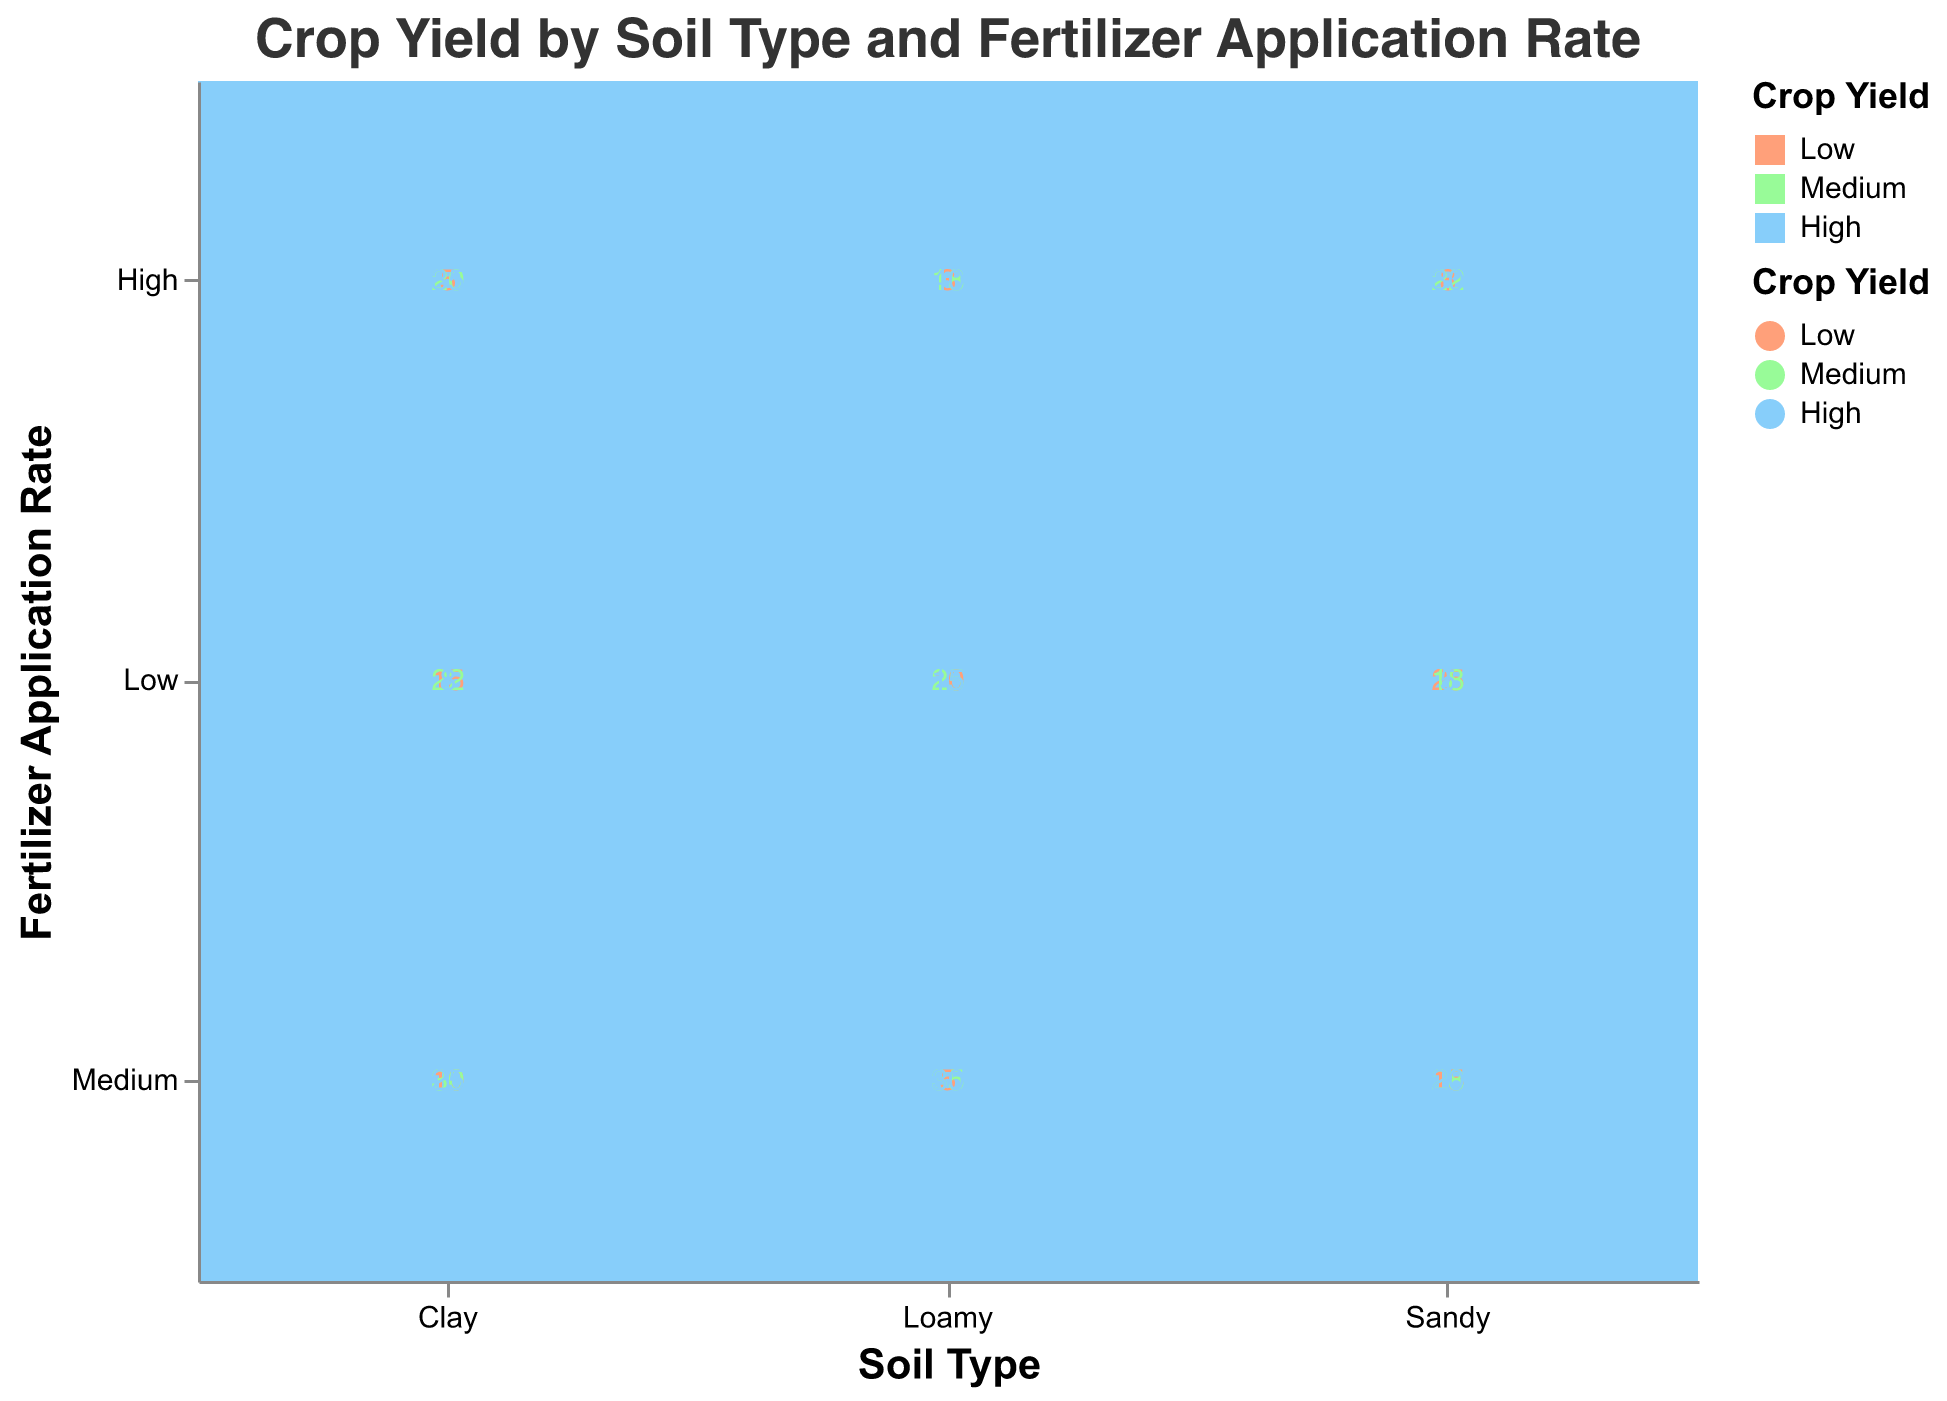what is the title of the figure? The title of the figure is displayed at the top and provides the main context of the visualized data.
Answer: Crop Yield by Soil Type and Fertilizer Application Rate what soil type has the highest crop yield for high fertilizer application rate? Locate the "High" Fertilizer Application Rate on the y-axis, then look for the highest crop yield within each soil type.
Answer: Loamy how many times is the medium fertilizer application rate used on clay soil? Focus on the "Medium" Fertilizer Application Rate within the "Clay" Soil Type, then sum the frequencies across all crop yields. The sum is 10 (Low) + 30 (Medium) + 25 (High).
Answer: 65 which soil type has the lowest crop yield for low fertilizer application rate? Identify the "Low" Fertilizer Application Rate on the y-axis, then look for the lowest crop yield values among the soil types.
Answer: Clay what's the total frequency of high crop yield across all soil types? Sum the frequencies for the "High" Crop Yield across all soil types and fertilizer application rates: 8 + 25 + 35 (Clay) + 5 + 20 + 30 (Sandy) + 15 + 30 + 40 (Loamy).
Answer: 208 which crop yield level appears most frequently in clay soil? Examine the "Clay" Soil Type and compare the frequencies of "Low," "Medium," and "High" Crop Yields.
Answer: Medium what is the frequency difference between low and high crop yields in sandy soil with medium fertilizer? Identify the frequencies for "Low" and "High" Crop Yields in "Sandy" Soil with "Medium" Fertilizer: 15 (Low) and 20 (High), then calculate the difference 20 - 15.
Answer: 5 compare the frequencies of medium crop yield for low fertilizer rates across all soil types Examine the "Low" Fertilizer Application Rate and compare the frequencies for "Medium" Crop Yield between "Clay" (22), "Sandy" (18), and "Loamy" (25).
Answer: Loamy > Clay > Sandy does high fertilizer application guarantee high crop yield in loamy soil? Check both the "High" Fertilizer Application Rate for "Loamy" Soil and the frequency of high crop yields to evaluate the guarantee. High fertilizer application does indeed result in the highest yield frequency of all groups for loamy soil.
Answer: Yes 